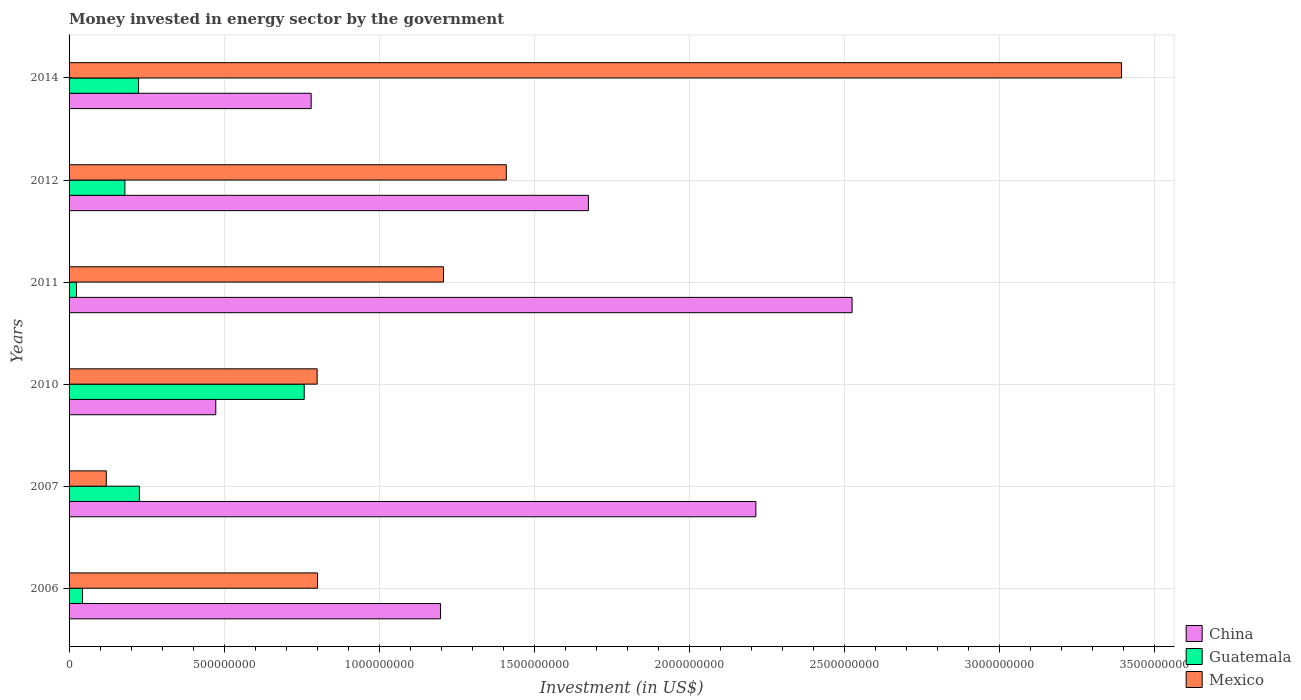How many groups of bars are there?
Keep it short and to the point. 6. How many bars are there on the 3rd tick from the bottom?
Your response must be concise. 3. What is the money spent in energy sector in Mexico in 2007?
Offer a very short reply. 1.20e+08. Across all years, what is the maximum money spent in energy sector in China?
Provide a short and direct response. 2.52e+09. Across all years, what is the minimum money spent in energy sector in Mexico?
Your answer should be very brief. 1.20e+08. In which year was the money spent in energy sector in Guatemala maximum?
Give a very brief answer. 2010. In which year was the money spent in energy sector in China minimum?
Offer a very short reply. 2010. What is the total money spent in energy sector in Guatemala in the graph?
Offer a terse response. 1.46e+09. What is the difference between the money spent in energy sector in Guatemala in 2006 and that in 2010?
Offer a very short reply. -7.14e+08. What is the difference between the money spent in energy sector in China in 2011 and the money spent in energy sector in Mexico in 2007?
Ensure brevity in your answer.  2.40e+09. What is the average money spent in energy sector in Mexico per year?
Provide a succinct answer. 1.29e+09. In the year 2006, what is the difference between the money spent in energy sector in Guatemala and money spent in energy sector in Mexico?
Your response must be concise. -7.58e+08. What is the ratio of the money spent in energy sector in China in 2010 to that in 2011?
Provide a succinct answer. 0.19. Is the money spent in energy sector in Mexico in 2007 less than that in 2012?
Offer a terse response. Yes. Is the difference between the money spent in energy sector in Guatemala in 2010 and 2012 greater than the difference between the money spent in energy sector in Mexico in 2010 and 2012?
Provide a short and direct response. Yes. What is the difference between the highest and the second highest money spent in energy sector in China?
Give a very brief answer. 3.10e+08. What is the difference between the highest and the lowest money spent in energy sector in Guatemala?
Your response must be concise. 7.34e+08. Is the sum of the money spent in energy sector in Mexico in 2006 and 2014 greater than the maximum money spent in energy sector in Guatemala across all years?
Provide a short and direct response. Yes. What does the 2nd bar from the top in 2014 represents?
Provide a succinct answer. Guatemala. What does the 2nd bar from the bottom in 2010 represents?
Your response must be concise. Guatemala. Are all the bars in the graph horizontal?
Your response must be concise. Yes. Does the graph contain any zero values?
Make the answer very short. No. Where does the legend appear in the graph?
Give a very brief answer. Bottom right. How are the legend labels stacked?
Offer a very short reply. Vertical. What is the title of the graph?
Provide a succinct answer. Money invested in energy sector by the government. Does "Dominican Republic" appear as one of the legend labels in the graph?
Your answer should be compact. No. What is the label or title of the X-axis?
Make the answer very short. Investment (in US$). What is the Investment (in US$) of China in 2006?
Offer a very short reply. 1.20e+09. What is the Investment (in US$) in Guatemala in 2006?
Offer a terse response. 4.35e+07. What is the Investment (in US$) in Mexico in 2006?
Your response must be concise. 8.01e+08. What is the Investment (in US$) in China in 2007?
Your answer should be very brief. 2.21e+09. What is the Investment (in US$) of Guatemala in 2007?
Make the answer very short. 2.27e+08. What is the Investment (in US$) of Mexico in 2007?
Provide a succinct answer. 1.20e+08. What is the Investment (in US$) in China in 2010?
Your response must be concise. 4.73e+08. What is the Investment (in US$) of Guatemala in 2010?
Offer a terse response. 7.58e+08. What is the Investment (in US$) in Mexico in 2010?
Your answer should be very brief. 8.00e+08. What is the Investment (in US$) of China in 2011?
Provide a succinct answer. 2.52e+09. What is the Investment (in US$) in Guatemala in 2011?
Your response must be concise. 2.40e+07. What is the Investment (in US$) of Mexico in 2011?
Your response must be concise. 1.21e+09. What is the Investment (in US$) of China in 2012?
Your answer should be compact. 1.67e+09. What is the Investment (in US$) of Guatemala in 2012?
Keep it short and to the point. 1.80e+08. What is the Investment (in US$) in Mexico in 2012?
Make the answer very short. 1.41e+09. What is the Investment (in US$) of China in 2014?
Give a very brief answer. 7.80e+08. What is the Investment (in US$) of Guatemala in 2014?
Keep it short and to the point. 2.24e+08. What is the Investment (in US$) in Mexico in 2014?
Give a very brief answer. 3.39e+09. Across all years, what is the maximum Investment (in US$) of China?
Give a very brief answer. 2.52e+09. Across all years, what is the maximum Investment (in US$) of Guatemala?
Offer a terse response. 7.58e+08. Across all years, what is the maximum Investment (in US$) in Mexico?
Ensure brevity in your answer.  3.39e+09. Across all years, what is the minimum Investment (in US$) of China?
Provide a short and direct response. 4.73e+08. Across all years, what is the minimum Investment (in US$) of Guatemala?
Provide a short and direct response. 2.40e+07. Across all years, what is the minimum Investment (in US$) in Mexico?
Your answer should be very brief. 1.20e+08. What is the total Investment (in US$) in China in the graph?
Make the answer very short. 8.86e+09. What is the total Investment (in US$) of Guatemala in the graph?
Ensure brevity in your answer.  1.46e+09. What is the total Investment (in US$) of Mexico in the graph?
Keep it short and to the point. 7.73e+09. What is the difference between the Investment (in US$) in China in 2006 and that in 2007?
Your answer should be compact. -1.02e+09. What is the difference between the Investment (in US$) in Guatemala in 2006 and that in 2007?
Ensure brevity in your answer.  -1.83e+08. What is the difference between the Investment (in US$) in Mexico in 2006 and that in 2007?
Give a very brief answer. 6.81e+08. What is the difference between the Investment (in US$) in China in 2006 and that in 2010?
Your answer should be very brief. 7.25e+08. What is the difference between the Investment (in US$) in Guatemala in 2006 and that in 2010?
Your answer should be compact. -7.14e+08. What is the difference between the Investment (in US$) of Mexico in 2006 and that in 2010?
Give a very brief answer. 1.30e+06. What is the difference between the Investment (in US$) of China in 2006 and that in 2011?
Your answer should be compact. -1.33e+09. What is the difference between the Investment (in US$) in Guatemala in 2006 and that in 2011?
Make the answer very short. 1.95e+07. What is the difference between the Investment (in US$) of Mexico in 2006 and that in 2011?
Provide a succinct answer. -4.06e+08. What is the difference between the Investment (in US$) in China in 2006 and that in 2012?
Ensure brevity in your answer.  -4.77e+08. What is the difference between the Investment (in US$) in Guatemala in 2006 and that in 2012?
Ensure brevity in your answer.  -1.36e+08. What is the difference between the Investment (in US$) of Mexico in 2006 and that in 2012?
Your answer should be compact. -6.08e+08. What is the difference between the Investment (in US$) of China in 2006 and that in 2014?
Provide a succinct answer. 4.17e+08. What is the difference between the Investment (in US$) of Guatemala in 2006 and that in 2014?
Provide a succinct answer. -1.80e+08. What is the difference between the Investment (in US$) in Mexico in 2006 and that in 2014?
Offer a terse response. -2.59e+09. What is the difference between the Investment (in US$) of China in 2007 and that in 2010?
Offer a terse response. 1.74e+09. What is the difference between the Investment (in US$) of Guatemala in 2007 and that in 2010?
Ensure brevity in your answer.  -5.31e+08. What is the difference between the Investment (in US$) in Mexico in 2007 and that in 2010?
Keep it short and to the point. -6.80e+08. What is the difference between the Investment (in US$) of China in 2007 and that in 2011?
Ensure brevity in your answer.  -3.10e+08. What is the difference between the Investment (in US$) in Guatemala in 2007 and that in 2011?
Provide a succinct answer. 2.03e+08. What is the difference between the Investment (in US$) in Mexico in 2007 and that in 2011?
Your answer should be compact. -1.09e+09. What is the difference between the Investment (in US$) in China in 2007 and that in 2012?
Provide a short and direct response. 5.40e+08. What is the difference between the Investment (in US$) of Guatemala in 2007 and that in 2012?
Provide a succinct answer. 4.68e+07. What is the difference between the Investment (in US$) in Mexico in 2007 and that in 2012?
Keep it short and to the point. -1.29e+09. What is the difference between the Investment (in US$) of China in 2007 and that in 2014?
Offer a very short reply. 1.43e+09. What is the difference between the Investment (in US$) in Guatemala in 2007 and that in 2014?
Make the answer very short. 2.80e+06. What is the difference between the Investment (in US$) of Mexico in 2007 and that in 2014?
Ensure brevity in your answer.  -3.27e+09. What is the difference between the Investment (in US$) of China in 2010 and that in 2011?
Offer a very short reply. -2.05e+09. What is the difference between the Investment (in US$) in Guatemala in 2010 and that in 2011?
Make the answer very short. 7.34e+08. What is the difference between the Investment (in US$) in Mexico in 2010 and that in 2011?
Your response must be concise. -4.07e+08. What is the difference between the Investment (in US$) of China in 2010 and that in 2012?
Give a very brief answer. -1.20e+09. What is the difference between the Investment (in US$) of Guatemala in 2010 and that in 2012?
Provide a succinct answer. 5.78e+08. What is the difference between the Investment (in US$) of Mexico in 2010 and that in 2012?
Give a very brief answer. -6.10e+08. What is the difference between the Investment (in US$) of China in 2010 and that in 2014?
Give a very brief answer. -3.07e+08. What is the difference between the Investment (in US$) in Guatemala in 2010 and that in 2014?
Offer a terse response. 5.34e+08. What is the difference between the Investment (in US$) of Mexico in 2010 and that in 2014?
Ensure brevity in your answer.  -2.59e+09. What is the difference between the Investment (in US$) of China in 2011 and that in 2012?
Your answer should be very brief. 8.50e+08. What is the difference between the Investment (in US$) in Guatemala in 2011 and that in 2012?
Offer a very short reply. -1.56e+08. What is the difference between the Investment (in US$) in Mexico in 2011 and that in 2012?
Provide a succinct answer. -2.02e+08. What is the difference between the Investment (in US$) of China in 2011 and that in 2014?
Give a very brief answer. 1.74e+09. What is the difference between the Investment (in US$) in Guatemala in 2011 and that in 2014?
Your answer should be very brief. -2.00e+08. What is the difference between the Investment (in US$) in Mexico in 2011 and that in 2014?
Your answer should be very brief. -2.19e+09. What is the difference between the Investment (in US$) of China in 2012 and that in 2014?
Make the answer very short. 8.94e+08. What is the difference between the Investment (in US$) of Guatemala in 2012 and that in 2014?
Keep it short and to the point. -4.40e+07. What is the difference between the Investment (in US$) of Mexico in 2012 and that in 2014?
Ensure brevity in your answer.  -1.98e+09. What is the difference between the Investment (in US$) of China in 2006 and the Investment (in US$) of Guatemala in 2007?
Give a very brief answer. 9.71e+08. What is the difference between the Investment (in US$) in China in 2006 and the Investment (in US$) in Mexico in 2007?
Your response must be concise. 1.08e+09. What is the difference between the Investment (in US$) of Guatemala in 2006 and the Investment (in US$) of Mexico in 2007?
Give a very brief answer. -7.65e+07. What is the difference between the Investment (in US$) in China in 2006 and the Investment (in US$) in Guatemala in 2010?
Your answer should be very brief. 4.40e+08. What is the difference between the Investment (in US$) in China in 2006 and the Investment (in US$) in Mexico in 2010?
Provide a succinct answer. 3.98e+08. What is the difference between the Investment (in US$) in Guatemala in 2006 and the Investment (in US$) in Mexico in 2010?
Offer a very short reply. -7.56e+08. What is the difference between the Investment (in US$) of China in 2006 and the Investment (in US$) of Guatemala in 2011?
Ensure brevity in your answer.  1.17e+09. What is the difference between the Investment (in US$) in China in 2006 and the Investment (in US$) in Mexico in 2011?
Provide a short and direct response. -9.42e+06. What is the difference between the Investment (in US$) in Guatemala in 2006 and the Investment (in US$) in Mexico in 2011?
Offer a very short reply. -1.16e+09. What is the difference between the Investment (in US$) of China in 2006 and the Investment (in US$) of Guatemala in 2012?
Offer a terse response. 1.02e+09. What is the difference between the Investment (in US$) of China in 2006 and the Investment (in US$) of Mexico in 2012?
Give a very brief answer. -2.12e+08. What is the difference between the Investment (in US$) of Guatemala in 2006 and the Investment (in US$) of Mexico in 2012?
Offer a terse response. -1.37e+09. What is the difference between the Investment (in US$) of China in 2006 and the Investment (in US$) of Guatemala in 2014?
Keep it short and to the point. 9.74e+08. What is the difference between the Investment (in US$) in China in 2006 and the Investment (in US$) in Mexico in 2014?
Provide a succinct answer. -2.20e+09. What is the difference between the Investment (in US$) of Guatemala in 2006 and the Investment (in US$) of Mexico in 2014?
Offer a terse response. -3.35e+09. What is the difference between the Investment (in US$) of China in 2007 and the Investment (in US$) of Guatemala in 2010?
Make the answer very short. 1.46e+09. What is the difference between the Investment (in US$) in China in 2007 and the Investment (in US$) in Mexico in 2010?
Your answer should be compact. 1.41e+09. What is the difference between the Investment (in US$) in Guatemala in 2007 and the Investment (in US$) in Mexico in 2010?
Your answer should be very brief. -5.73e+08. What is the difference between the Investment (in US$) of China in 2007 and the Investment (in US$) of Guatemala in 2011?
Offer a terse response. 2.19e+09. What is the difference between the Investment (in US$) in China in 2007 and the Investment (in US$) in Mexico in 2011?
Keep it short and to the point. 1.01e+09. What is the difference between the Investment (in US$) of Guatemala in 2007 and the Investment (in US$) of Mexico in 2011?
Give a very brief answer. -9.80e+08. What is the difference between the Investment (in US$) in China in 2007 and the Investment (in US$) in Guatemala in 2012?
Provide a short and direct response. 2.03e+09. What is the difference between the Investment (in US$) of China in 2007 and the Investment (in US$) of Mexico in 2012?
Your response must be concise. 8.05e+08. What is the difference between the Investment (in US$) of Guatemala in 2007 and the Investment (in US$) of Mexico in 2012?
Keep it short and to the point. -1.18e+09. What is the difference between the Investment (in US$) in China in 2007 and the Investment (in US$) in Guatemala in 2014?
Give a very brief answer. 1.99e+09. What is the difference between the Investment (in US$) in China in 2007 and the Investment (in US$) in Mexico in 2014?
Provide a succinct answer. -1.18e+09. What is the difference between the Investment (in US$) of Guatemala in 2007 and the Investment (in US$) of Mexico in 2014?
Your response must be concise. -3.17e+09. What is the difference between the Investment (in US$) of China in 2010 and the Investment (in US$) of Guatemala in 2011?
Your answer should be very brief. 4.49e+08. What is the difference between the Investment (in US$) of China in 2010 and the Investment (in US$) of Mexico in 2011?
Your answer should be compact. -7.34e+08. What is the difference between the Investment (in US$) in Guatemala in 2010 and the Investment (in US$) in Mexico in 2011?
Your response must be concise. -4.49e+08. What is the difference between the Investment (in US$) in China in 2010 and the Investment (in US$) in Guatemala in 2012?
Offer a terse response. 2.93e+08. What is the difference between the Investment (in US$) in China in 2010 and the Investment (in US$) in Mexico in 2012?
Offer a very short reply. -9.37e+08. What is the difference between the Investment (in US$) in Guatemala in 2010 and the Investment (in US$) in Mexico in 2012?
Your response must be concise. -6.52e+08. What is the difference between the Investment (in US$) of China in 2010 and the Investment (in US$) of Guatemala in 2014?
Provide a succinct answer. 2.49e+08. What is the difference between the Investment (in US$) of China in 2010 and the Investment (in US$) of Mexico in 2014?
Your response must be concise. -2.92e+09. What is the difference between the Investment (in US$) in Guatemala in 2010 and the Investment (in US$) in Mexico in 2014?
Your response must be concise. -2.63e+09. What is the difference between the Investment (in US$) in China in 2011 and the Investment (in US$) in Guatemala in 2012?
Keep it short and to the point. 2.34e+09. What is the difference between the Investment (in US$) of China in 2011 and the Investment (in US$) of Mexico in 2012?
Your answer should be compact. 1.11e+09. What is the difference between the Investment (in US$) in Guatemala in 2011 and the Investment (in US$) in Mexico in 2012?
Give a very brief answer. -1.39e+09. What is the difference between the Investment (in US$) of China in 2011 and the Investment (in US$) of Guatemala in 2014?
Ensure brevity in your answer.  2.30e+09. What is the difference between the Investment (in US$) in China in 2011 and the Investment (in US$) in Mexico in 2014?
Keep it short and to the point. -8.69e+08. What is the difference between the Investment (in US$) in Guatemala in 2011 and the Investment (in US$) in Mexico in 2014?
Keep it short and to the point. -3.37e+09. What is the difference between the Investment (in US$) in China in 2012 and the Investment (in US$) in Guatemala in 2014?
Give a very brief answer. 1.45e+09. What is the difference between the Investment (in US$) in China in 2012 and the Investment (in US$) in Mexico in 2014?
Your response must be concise. -1.72e+09. What is the difference between the Investment (in US$) of Guatemala in 2012 and the Investment (in US$) of Mexico in 2014?
Your answer should be compact. -3.21e+09. What is the average Investment (in US$) in China per year?
Give a very brief answer. 1.48e+09. What is the average Investment (in US$) in Guatemala per year?
Offer a terse response. 2.43e+08. What is the average Investment (in US$) of Mexico per year?
Offer a very short reply. 1.29e+09. In the year 2006, what is the difference between the Investment (in US$) of China and Investment (in US$) of Guatemala?
Provide a short and direct response. 1.15e+09. In the year 2006, what is the difference between the Investment (in US$) of China and Investment (in US$) of Mexico?
Your response must be concise. 3.97e+08. In the year 2006, what is the difference between the Investment (in US$) in Guatemala and Investment (in US$) in Mexico?
Provide a short and direct response. -7.58e+08. In the year 2007, what is the difference between the Investment (in US$) in China and Investment (in US$) in Guatemala?
Make the answer very short. 1.99e+09. In the year 2007, what is the difference between the Investment (in US$) of China and Investment (in US$) of Mexico?
Make the answer very short. 2.09e+09. In the year 2007, what is the difference between the Investment (in US$) in Guatemala and Investment (in US$) in Mexico?
Give a very brief answer. 1.07e+08. In the year 2010, what is the difference between the Investment (in US$) in China and Investment (in US$) in Guatemala?
Your answer should be compact. -2.85e+08. In the year 2010, what is the difference between the Investment (in US$) of China and Investment (in US$) of Mexico?
Make the answer very short. -3.27e+08. In the year 2010, what is the difference between the Investment (in US$) in Guatemala and Investment (in US$) in Mexico?
Your answer should be compact. -4.17e+07. In the year 2011, what is the difference between the Investment (in US$) of China and Investment (in US$) of Guatemala?
Provide a short and direct response. 2.50e+09. In the year 2011, what is the difference between the Investment (in US$) in China and Investment (in US$) in Mexico?
Make the answer very short. 1.32e+09. In the year 2011, what is the difference between the Investment (in US$) in Guatemala and Investment (in US$) in Mexico?
Make the answer very short. -1.18e+09. In the year 2012, what is the difference between the Investment (in US$) of China and Investment (in US$) of Guatemala?
Your answer should be compact. 1.49e+09. In the year 2012, what is the difference between the Investment (in US$) of China and Investment (in US$) of Mexico?
Keep it short and to the point. 2.65e+08. In the year 2012, what is the difference between the Investment (in US$) of Guatemala and Investment (in US$) of Mexico?
Your answer should be very brief. -1.23e+09. In the year 2014, what is the difference between the Investment (in US$) in China and Investment (in US$) in Guatemala?
Your answer should be compact. 5.56e+08. In the year 2014, what is the difference between the Investment (in US$) of China and Investment (in US$) of Mexico?
Keep it short and to the point. -2.61e+09. In the year 2014, what is the difference between the Investment (in US$) of Guatemala and Investment (in US$) of Mexico?
Make the answer very short. -3.17e+09. What is the ratio of the Investment (in US$) in China in 2006 to that in 2007?
Make the answer very short. 0.54. What is the ratio of the Investment (in US$) of Guatemala in 2006 to that in 2007?
Offer a terse response. 0.19. What is the ratio of the Investment (in US$) of Mexico in 2006 to that in 2007?
Make the answer very short. 6.67. What is the ratio of the Investment (in US$) in China in 2006 to that in 2010?
Your answer should be compact. 2.53. What is the ratio of the Investment (in US$) of Guatemala in 2006 to that in 2010?
Your response must be concise. 0.06. What is the ratio of the Investment (in US$) of Mexico in 2006 to that in 2010?
Offer a terse response. 1. What is the ratio of the Investment (in US$) of China in 2006 to that in 2011?
Keep it short and to the point. 0.47. What is the ratio of the Investment (in US$) in Guatemala in 2006 to that in 2011?
Provide a succinct answer. 1.81. What is the ratio of the Investment (in US$) of Mexico in 2006 to that in 2011?
Keep it short and to the point. 0.66. What is the ratio of the Investment (in US$) in China in 2006 to that in 2012?
Provide a short and direct response. 0.72. What is the ratio of the Investment (in US$) of Guatemala in 2006 to that in 2012?
Keep it short and to the point. 0.24. What is the ratio of the Investment (in US$) in Mexico in 2006 to that in 2012?
Your answer should be compact. 0.57. What is the ratio of the Investment (in US$) in China in 2006 to that in 2014?
Ensure brevity in your answer.  1.53. What is the ratio of the Investment (in US$) of Guatemala in 2006 to that in 2014?
Make the answer very short. 0.19. What is the ratio of the Investment (in US$) of Mexico in 2006 to that in 2014?
Ensure brevity in your answer.  0.24. What is the ratio of the Investment (in US$) of China in 2007 to that in 2010?
Provide a succinct answer. 4.68. What is the ratio of the Investment (in US$) of Guatemala in 2007 to that in 2010?
Your answer should be compact. 0.3. What is the ratio of the Investment (in US$) in Mexico in 2007 to that in 2010?
Offer a very short reply. 0.15. What is the ratio of the Investment (in US$) of China in 2007 to that in 2011?
Offer a terse response. 0.88. What is the ratio of the Investment (in US$) of Guatemala in 2007 to that in 2011?
Make the answer very short. 9.45. What is the ratio of the Investment (in US$) in Mexico in 2007 to that in 2011?
Your answer should be compact. 0.1. What is the ratio of the Investment (in US$) in China in 2007 to that in 2012?
Offer a very short reply. 1.32. What is the ratio of the Investment (in US$) of Guatemala in 2007 to that in 2012?
Give a very brief answer. 1.26. What is the ratio of the Investment (in US$) of Mexico in 2007 to that in 2012?
Your answer should be very brief. 0.09. What is the ratio of the Investment (in US$) in China in 2007 to that in 2014?
Give a very brief answer. 2.84. What is the ratio of the Investment (in US$) of Guatemala in 2007 to that in 2014?
Make the answer very short. 1.01. What is the ratio of the Investment (in US$) in Mexico in 2007 to that in 2014?
Offer a very short reply. 0.04. What is the ratio of the Investment (in US$) in China in 2010 to that in 2011?
Keep it short and to the point. 0.19. What is the ratio of the Investment (in US$) of Guatemala in 2010 to that in 2011?
Your response must be concise. 31.58. What is the ratio of the Investment (in US$) of Mexico in 2010 to that in 2011?
Give a very brief answer. 0.66. What is the ratio of the Investment (in US$) in China in 2010 to that in 2012?
Ensure brevity in your answer.  0.28. What is the ratio of the Investment (in US$) of Guatemala in 2010 to that in 2012?
Provide a succinct answer. 4.21. What is the ratio of the Investment (in US$) in Mexico in 2010 to that in 2012?
Ensure brevity in your answer.  0.57. What is the ratio of the Investment (in US$) in China in 2010 to that in 2014?
Keep it short and to the point. 0.61. What is the ratio of the Investment (in US$) of Guatemala in 2010 to that in 2014?
Ensure brevity in your answer.  3.38. What is the ratio of the Investment (in US$) of Mexico in 2010 to that in 2014?
Provide a succinct answer. 0.24. What is the ratio of the Investment (in US$) of China in 2011 to that in 2012?
Your response must be concise. 1.51. What is the ratio of the Investment (in US$) in Guatemala in 2011 to that in 2012?
Offer a terse response. 0.13. What is the ratio of the Investment (in US$) of Mexico in 2011 to that in 2012?
Your response must be concise. 0.86. What is the ratio of the Investment (in US$) of China in 2011 to that in 2014?
Keep it short and to the point. 3.23. What is the ratio of the Investment (in US$) of Guatemala in 2011 to that in 2014?
Give a very brief answer. 0.11. What is the ratio of the Investment (in US$) in Mexico in 2011 to that in 2014?
Make the answer very short. 0.36. What is the ratio of the Investment (in US$) of China in 2012 to that in 2014?
Provide a succinct answer. 2.15. What is the ratio of the Investment (in US$) of Guatemala in 2012 to that in 2014?
Keep it short and to the point. 0.8. What is the ratio of the Investment (in US$) in Mexico in 2012 to that in 2014?
Offer a very short reply. 0.42. What is the difference between the highest and the second highest Investment (in US$) of China?
Your response must be concise. 3.10e+08. What is the difference between the highest and the second highest Investment (in US$) of Guatemala?
Make the answer very short. 5.31e+08. What is the difference between the highest and the second highest Investment (in US$) in Mexico?
Offer a very short reply. 1.98e+09. What is the difference between the highest and the lowest Investment (in US$) of China?
Ensure brevity in your answer.  2.05e+09. What is the difference between the highest and the lowest Investment (in US$) of Guatemala?
Your answer should be compact. 7.34e+08. What is the difference between the highest and the lowest Investment (in US$) in Mexico?
Ensure brevity in your answer.  3.27e+09. 